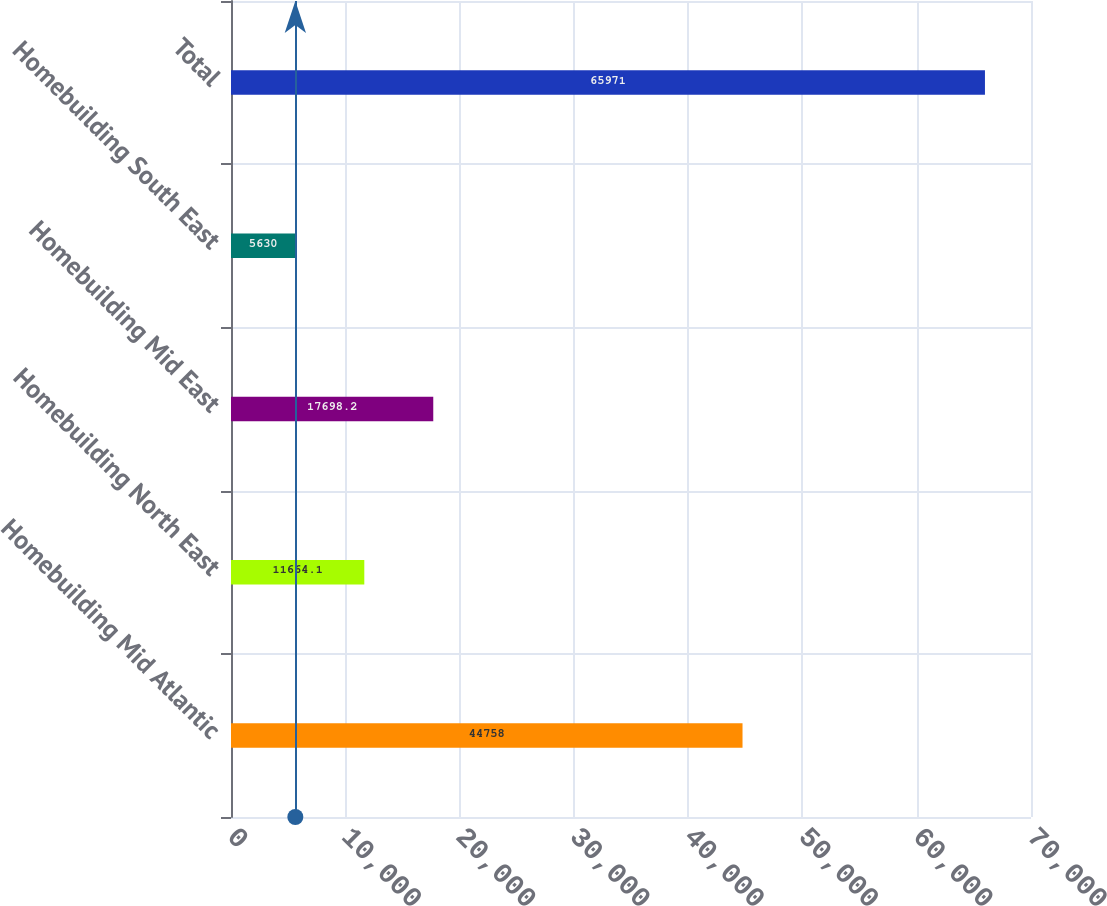<chart> <loc_0><loc_0><loc_500><loc_500><bar_chart><fcel>Homebuilding Mid Atlantic<fcel>Homebuilding North East<fcel>Homebuilding Mid East<fcel>Homebuilding South East<fcel>Total<nl><fcel>44758<fcel>11664.1<fcel>17698.2<fcel>5630<fcel>65971<nl></chart> 